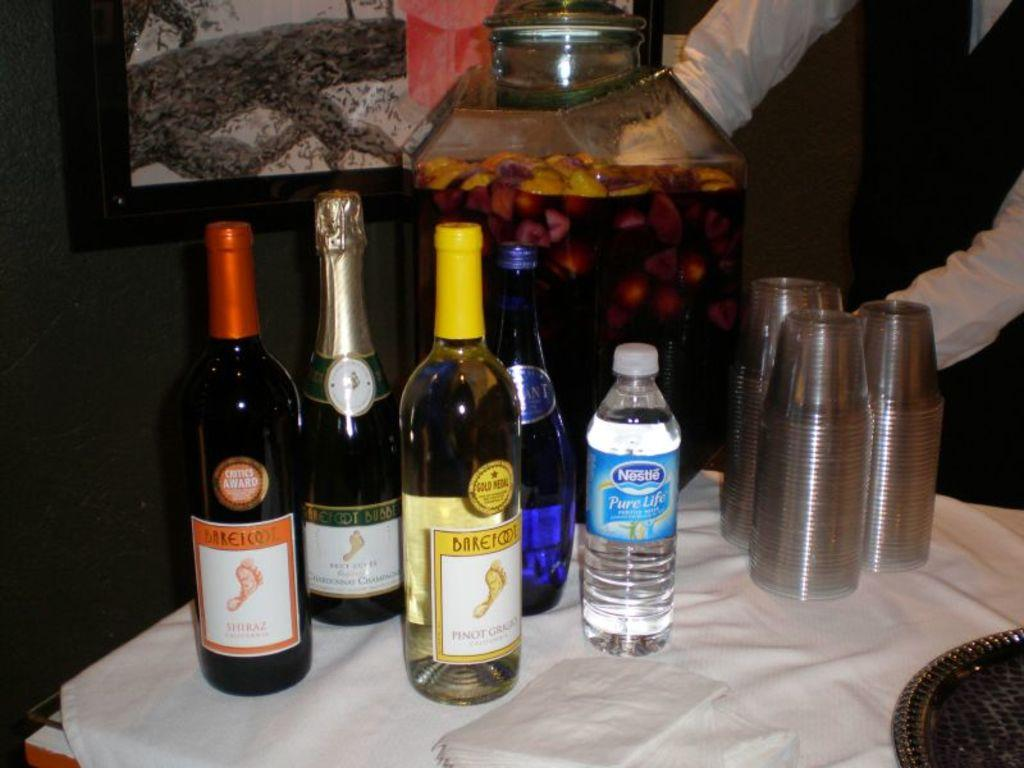Provide a one-sentence caption for the provided image. Several bottles of Barefoot wine sitting on a table next to nestle purelife water and cups. 